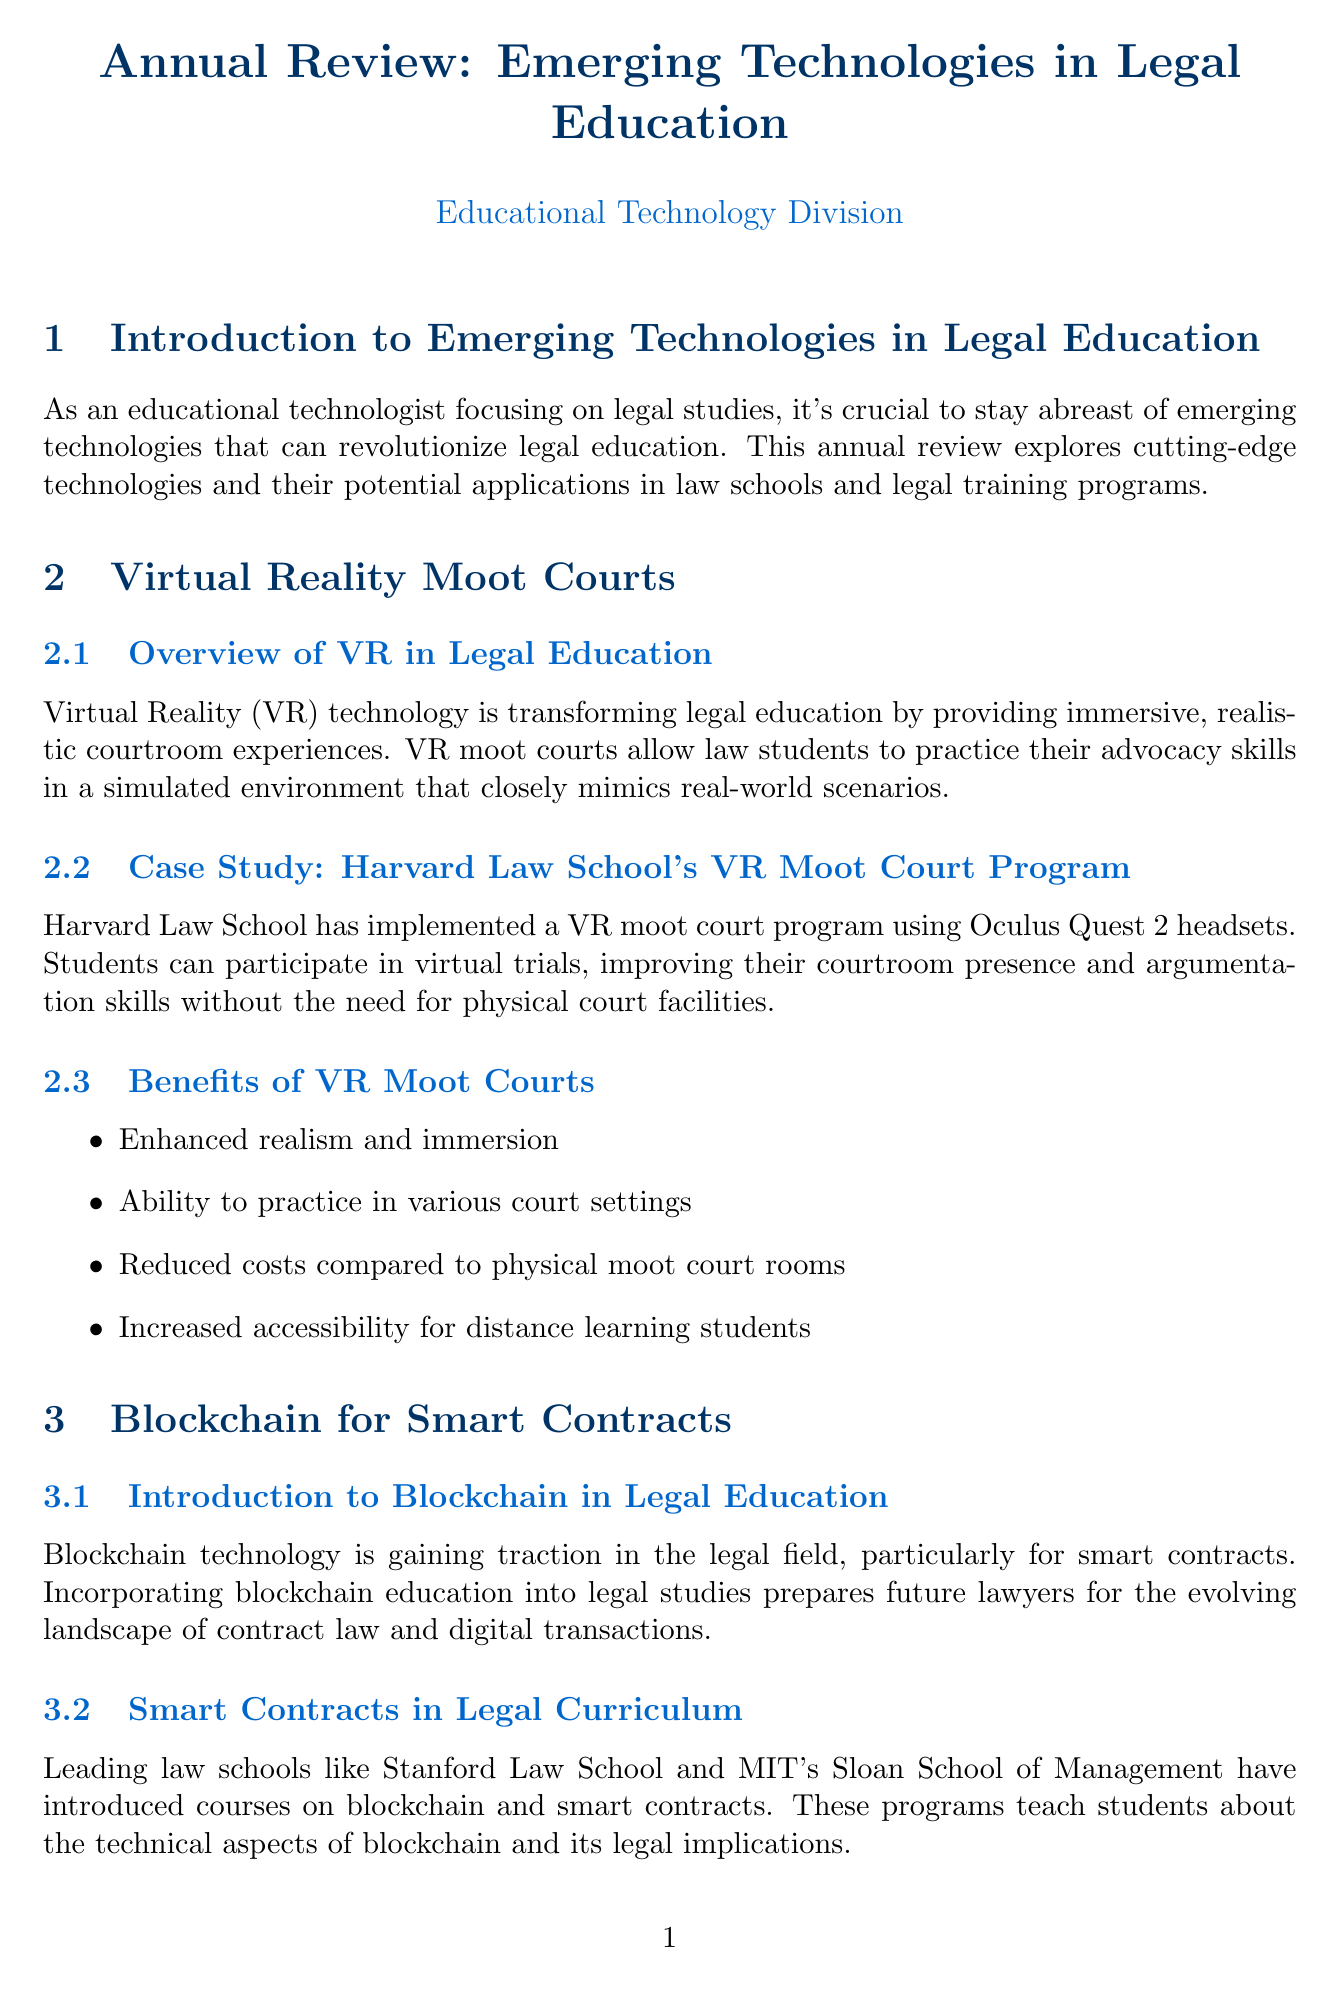What is the title of the report? The title of the report is given at the beginning of the document which is an overview of emerging technologies in legal education.
Answer: Annual Review: Emerging Technologies in Legal Education Which technology is used in Harvard Law School's moot court program? The document states that Harvard Law School uses a specific type of technology in their VR moot court program.
Answer: Oculus Quest 2 What are the benefits of VR moot courts? The document lists several benefits of VR moot courts among which one key benefit stands out clearly.
Answer: Enhanced realism and immersion What type of course have leading law schools introduced related to blockchain? The document highlights a specific type of course that focuses on a relevant technology and its applications in law.
Answer: Courses on blockchain and smart contracts Which university partnered with Blue J Legal? The document details a collaboration relevant to utilizing AI in legal education specifying a particular university directly.
Answer: University of Toronto Faculty of Law How many recommendations are given for implementing technologies in legal education? The recommendations section contains specific numbered advice on technology implementation in legal education.
Answer: Four What is the focus of gamification in legal studies? The document explains the primary purpose of gamification related to the engagement of students in legal education.
Answer: Make legal education more engaging and interactive What year was "The Future of Legal Education and Digital Skills" published? The document specifies the publication year of a certain book relevant to legal education and technology.
Answer: 2022 What is the primary purpose of incorporating blockchain education into legal studies? The document discusses the rationale behind including blockchain in legal education, emphasizing the implications for future lawyers.
Answer: Evolving landscape of contract law and digital transactions 